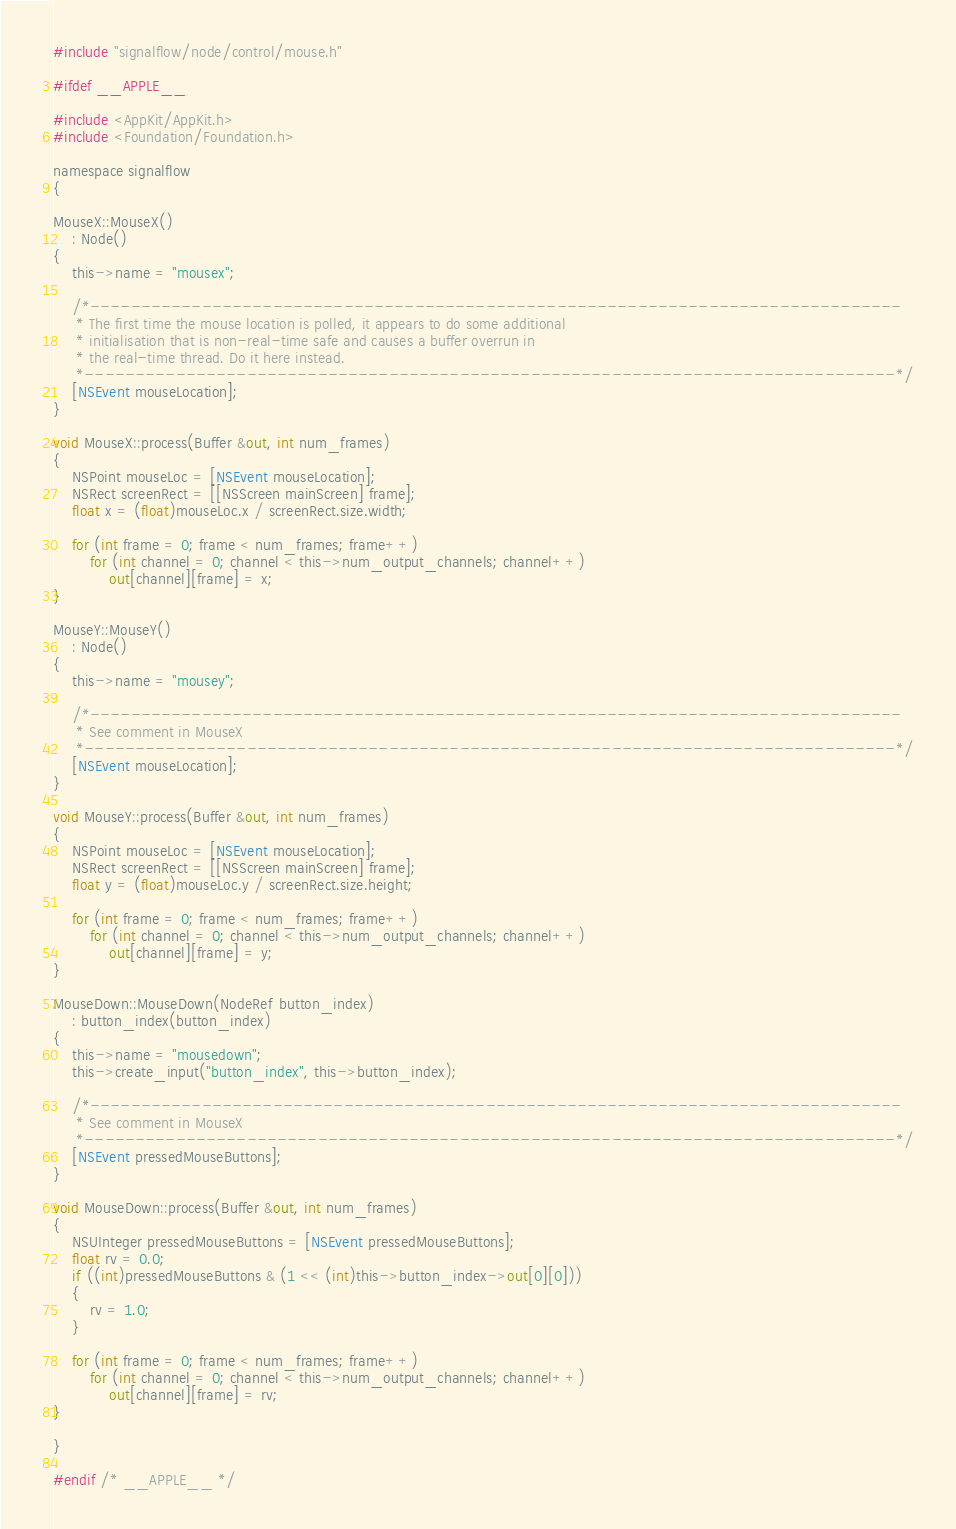Convert code to text. <code><loc_0><loc_0><loc_500><loc_500><_ObjectiveC_>#include "signalflow/node/control/mouse.h"

#ifdef __APPLE__

#include <AppKit/AppKit.h>
#include <Foundation/Foundation.h>

namespace signalflow
{

MouseX::MouseX()
    : Node()
{
    this->name = "mousex";

    /*--------------------------------------------------------------------------------
     * The first time the mouse location is polled, it appears to do some additional
     * initialisation that is non-real-time safe and causes a buffer overrun in
     * the real-time thread. Do it here instead.
     *--------------------------------------------------------------------------------*/
    [NSEvent mouseLocation];
}

void MouseX::process(Buffer &out, int num_frames)
{
    NSPoint mouseLoc = [NSEvent mouseLocation];
    NSRect screenRect = [[NSScreen mainScreen] frame];
    float x = (float)mouseLoc.x / screenRect.size.width;

    for (int frame = 0; frame < num_frames; frame++)
        for (int channel = 0; channel < this->num_output_channels; channel++)
            out[channel][frame] = x;
}

MouseY::MouseY()
    : Node()
{
    this->name = "mousey";

    /*--------------------------------------------------------------------------------
     * See comment in MouseX
     *--------------------------------------------------------------------------------*/
    [NSEvent mouseLocation];
}

void MouseY::process(Buffer &out, int num_frames)
{
    NSPoint mouseLoc = [NSEvent mouseLocation];
    NSRect screenRect = [[NSScreen mainScreen] frame];
    float y = (float)mouseLoc.y / screenRect.size.height;

    for (int frame = 0; frame < num_frames; frame++)
        for (int channel = 0; channel < this->num_output_channels; channel++)
            out[channel][frame] = y;
}

MouseDown::MouseDown(NodeRef button_index)
    : button_index(button_index)
{
    this->name = "mousedown";
    this->create_input("button_index", this->button_index);

    /*--------------------------------------------------------------------------------
     * See comment in MouseX
     *--------------------------------------------------------------------------------*/
    [NSEvent pressedMouseButtons];
}

void MouseDown::process(Buffer &out, int num_frames)
{
    NSUInteger pressedMouseButtons = [NSEvent pressedMouseButtons];
    float rv = 0.0;
    if ((int)pressedMouseButtons & (1 << (int)this->button_index->out[0][0]))
    {
        rv = 1.0;
    }

    for (int frame = 0; frame < num_frames; frame++)
        for (int channel = 0; channel < this->num_output_channels; channel++)
            out[channel][frame] = rv;
}

}

#endif /* __APPLE__ */
</code> 